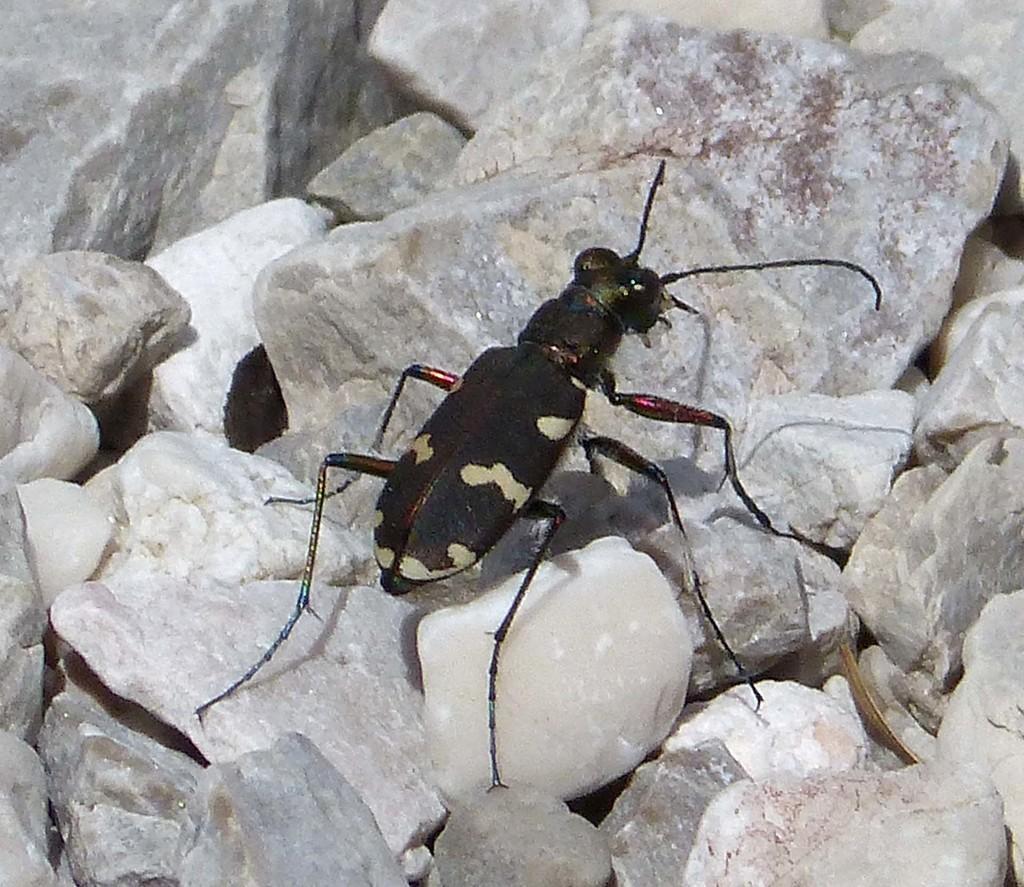Describe this image in one or two sentences. This is the tiger beetle, which is black in color. These are the rocks. 